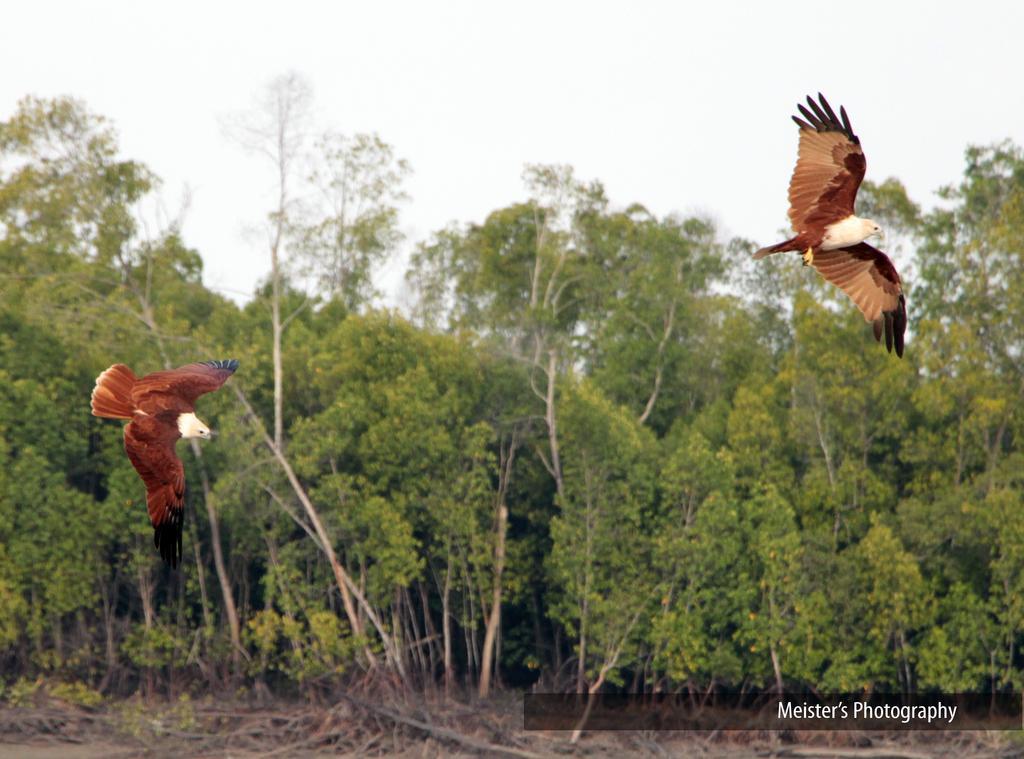Describe this image in one or two sentences. In this image I can see two birds, text, trees and the sky. This image is taken may be during a day. 